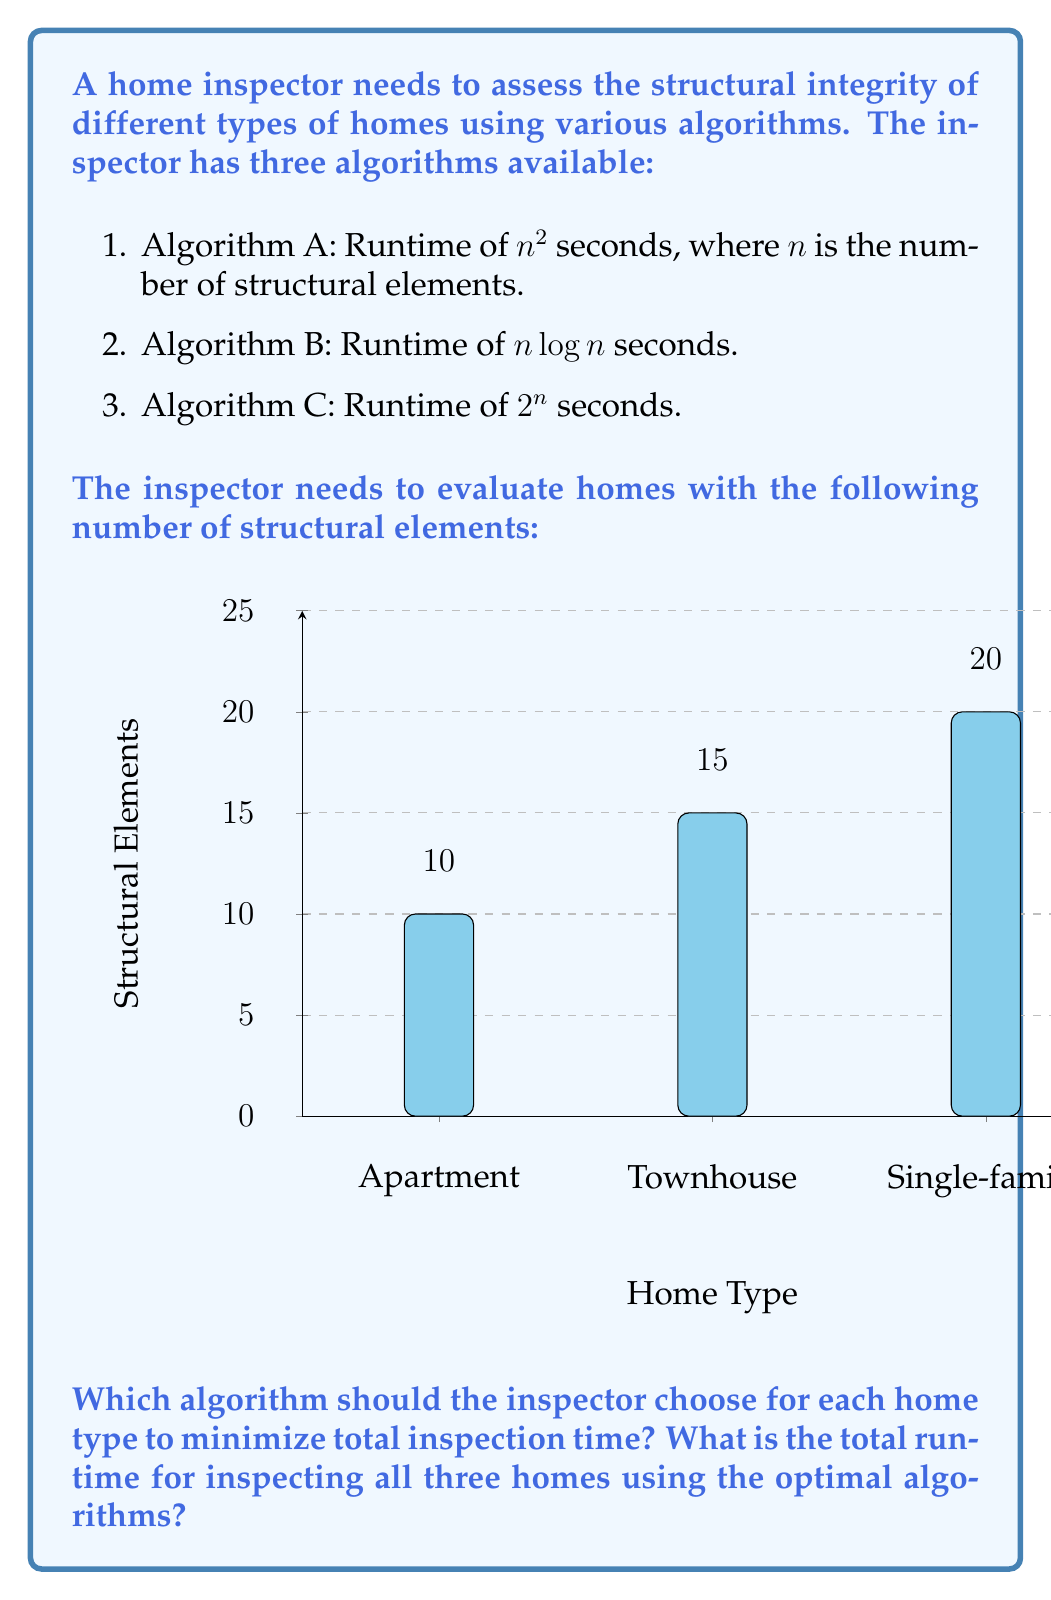Solve this math problem. Let's analyze the runtime for each algorithm and home type:

1. Apartment (10 structural elements):
   - Algorithm A: $10^2 = 100$ seconds
   - Algorithm B: $10 \log 10 \approx 33.22$ seconds
   - Algorithm C: $2^{10} = 1024$ seconds

2. Townhouse (15 structural elements):
   - Algorithm A: $15^2 = 225$ seconds
   - Algorithm B: $15 \log 15 \approx 58.60$ seconds
   - Algorithm C: $2^{15} = 32768$ seconds

3. Single-family home (20 structural elements):
   - Algorithm A: $20^2 = 400$ seconds
   - Algorithm B: $20 \log 20 \approx 86.44$ seconds
   - Algorithm C: $2^{20} = 1048576$ seconds

Optimal choices:
- For the apartment: Algorithm B (33.22 seconds)
- For the townhouse: Algorithm B (58.60 seconds)
- For the single-family home: Algorithm B (86.44 seconds)

Total runtime using optimal algorithms:
$$33.22 + 58.60 + 86.44 = 178.26 \text{ seconds}$$

Algorithm B ($n \log n$) is the most efficient for all home types in this scenario. As $n$ increases, it consistently outperforms the other algorithms.
Answer: Choose Algorithm B for all home types; total runtime ≈ 178.26 seconds. 